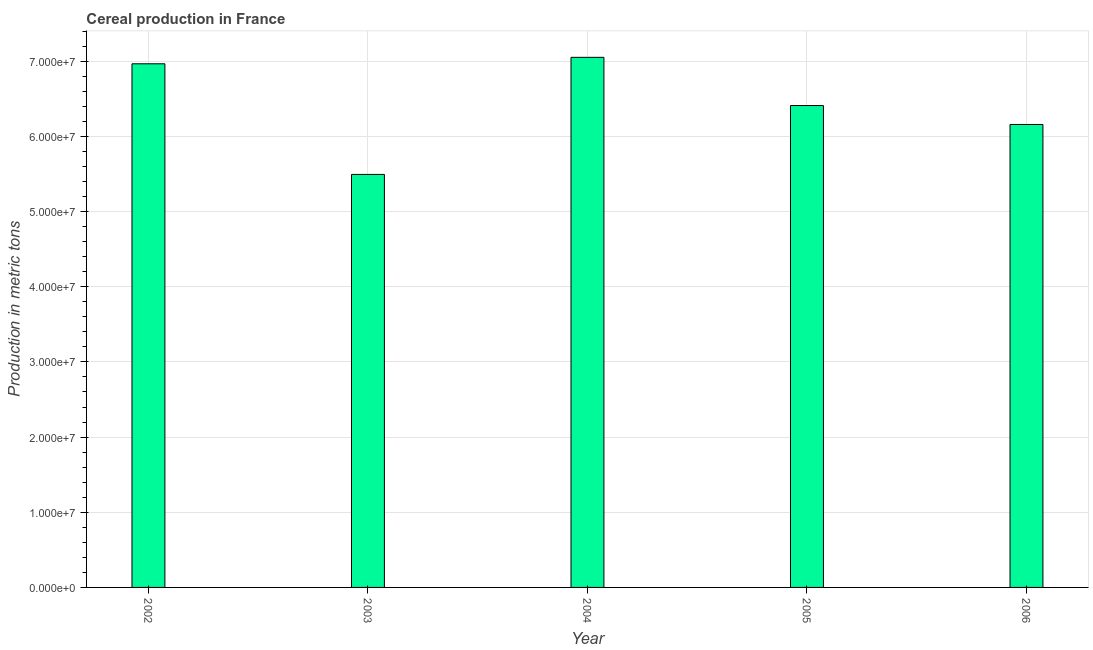Does the graph contain any zero values?
Provide a succinct answer. No. What is the title of the graph?
Provide a succinct answer. Cereal production in France. What is the label or title of the X-axis?
Provide a short and direct response. Year. What is the label or title of the Y-axis?
Your answer should be very brief. Production in metric tons. What is the cereal production in 2004?
Your answer should be very brief. 7.05e+07. Across all years, what is the maximum cereal production?
Offer a terse response. 7.05e+07. Across all years, what is the minimum cereal production?
Your answer should be compact. 5.49e+07. In which year was the cereal production maximum?
Provide a short and direct response. 2004. In which year was the cereal production minimum?
Your answer should be very brief. 2003. What is the sum of the cereal production?
Provide a succinct answer. 3.21e+08. What is the difference between the cereal production in 2002 and 2003?
Ensure brevity in your answer.  1.47e+07. What is the average cereal production per year?
Give a very brief answer. 6.42e+07. What is the median cereal production?
Keep it short and to the point. 6.41e+07. What is the ratio of the cereal production in 2002 to that in 2003?
Offer a very short reply. 1.27. Is the difference between the cereal production in 2003 and 2005 greater than the difference between any two years?
Your answer should be very brief. No. What is the difference between the highest and the second highest cereal production?
Provide a succinct answer. 8.60e+05. Is the sum of the cereal production in 2002 and 2005 greater than the maximum cereal production across all years?
Offer a terse response. Yes. What is the difference between the highest and the lowest cereal production?
Offer a very short reply. 1.56e+07. In how many years, is the cereal production greater than the average cereal production taken over all years?
Give a very brief answer. 2. Are all the bars in the graph horizontal?
Your response must be concise. No. Are the values on the major ticks of Y-axis written in scientific E-notation?
Your response must be concise. Yes. What is the Production in metric tons of 2002?
Ensure brevity in your answer.  6.97e+07. What is the Production in metric tons in 2003?
Make the answer very short. 5.49e+07. What is the Production in metric tons in 2004?
Give a very brief answer. 7.05e+07. What is the Production in metric tons of 2005?
Offer a very short reply. 6.41e+07. What is the Production in metric tons in 2006?
Offer a very short reply. 6.16e+07. What is the difference between the Production in metric tons in 2002 and 2003?
Your response must be concise. 1.47e+07. What is the difference between the Production in metric tons in 2002 and 2004?
Offer a terse response. -8.60e+05. What is the difference between the Production in metric tons in 2002 and 2005?
Your answer should be very brief. 5.55e+06. What is the difference between the Production in metric tons in 2002 and 2006?
Provide a short and direct response. 8.07e+06. What is the difference between the Production in metric tons in 2003 and 2004?
Your answer should be very brief. -1.56e+07. What is the difference between the Production in metric tons in 2003 and 2005?
Keep it short and to the point. -9.16e+06. What is the difference between the Production in metric tons in 2003 and 2006?
Give a very brief answer. -6.64e+06. What is the difference between the Production in metric tons in 2004 and 2005?
Your response must be concise. 6.41e+06. What is the difference between the Production in metric tons in 2004 and 2006?
Your answer should be compact. 8.93e+06. What is the difference between the Production in metric tons in 2005 and 2006?
Your response must be concise. 2.52e+06. What is the ratio of the Production in metric tons in 2002 to that in 2003?
Keep it short and to the point. 1.27. What is the ratio of the Production in metric tons in 2002 to that in 2004?
Provide a short and direct response. 0.99. What is the ratio of the Production in metric tons in 2002 to that in 2005?
Give a very brief answer. 1.09. What is the ratio of the Production in metric tons in 2002 to that in 2006?
Offer a terse response. 1.13. What is the ratio of the Production in metric tons in 2003 to that in 2004?
Make the answer very short. 0.78. What is the ratio of the Production in metric tons in 2003 to that in 2005?
Your answer should be very brief. 0.86. What is the ratio of the Production in metric tons in 2003 to that in 2006?
Offer a very short reply. 0.89. What is the ratio of the Production in metric tons in 2004 to that in 2005?
Keep it short and to the point. 1.1. What is the ratio of the Production in metric tons in 2004 to that in 2006?
Make the answer very short. 1.15. What is the ratio of the Production in metric tons in 2005 to that in 2006?
Offer a very short reply. 1.04. 